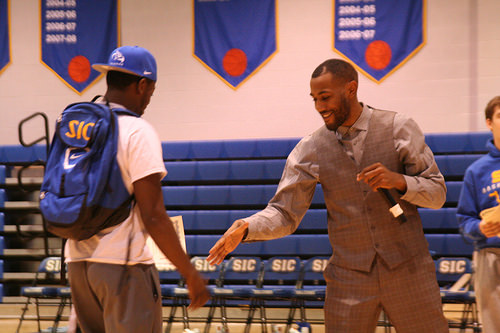<image>
Is there a microphone behind the fist? No. The microphone is not behind the fist. From this viewpoint, the microphone appears to be positioned elsewhere in the scene. Where is the flag in relation to the mic? Is it above the mic? No. The flag is not positioned above the mic. The vertical arrangement shows a different relationship. 